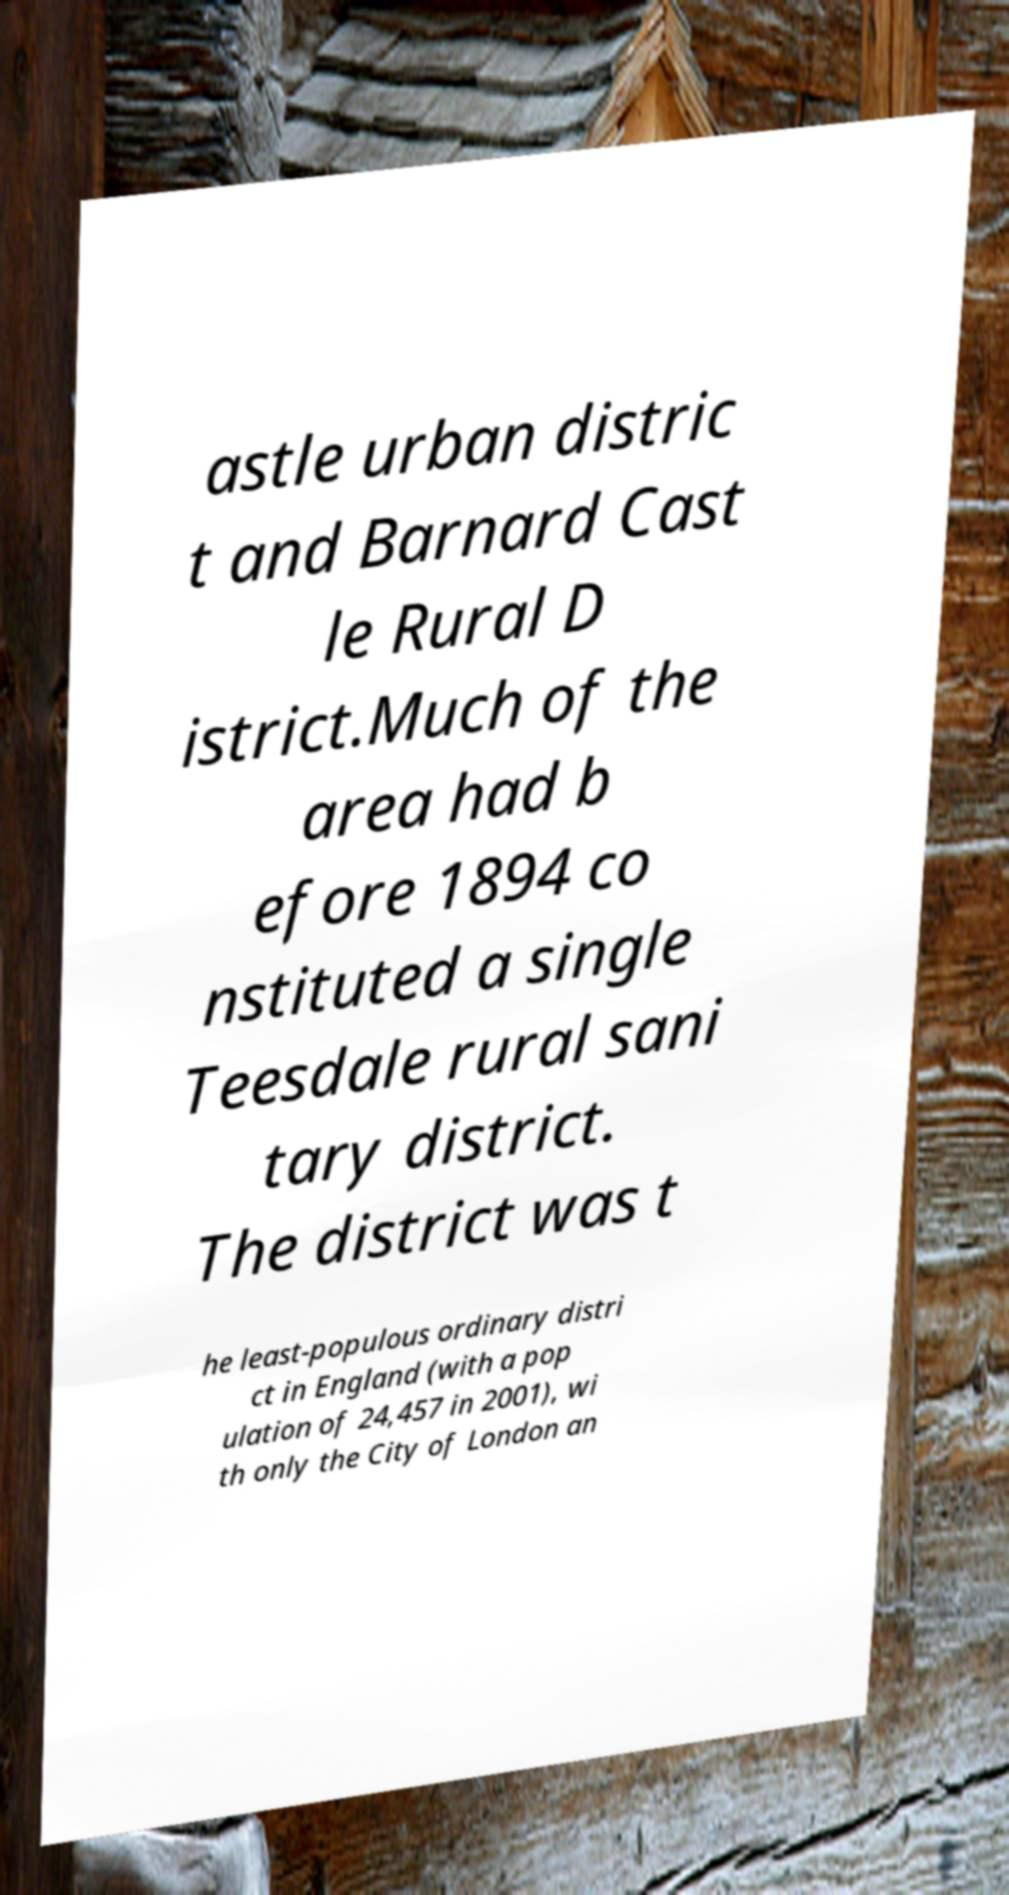What messages or text are displayed in this image? I need them in a readable, typed format. astle urban distric t and Barnard Cast le Rural D istrict.Much of the area had b efore 1894 co nstituted a single Teesdale rural sani tary district. The district was t he least-populous ordinary distri ct in England (with a pop ulation of 24,457 in 2001), wi th only the City of London an 